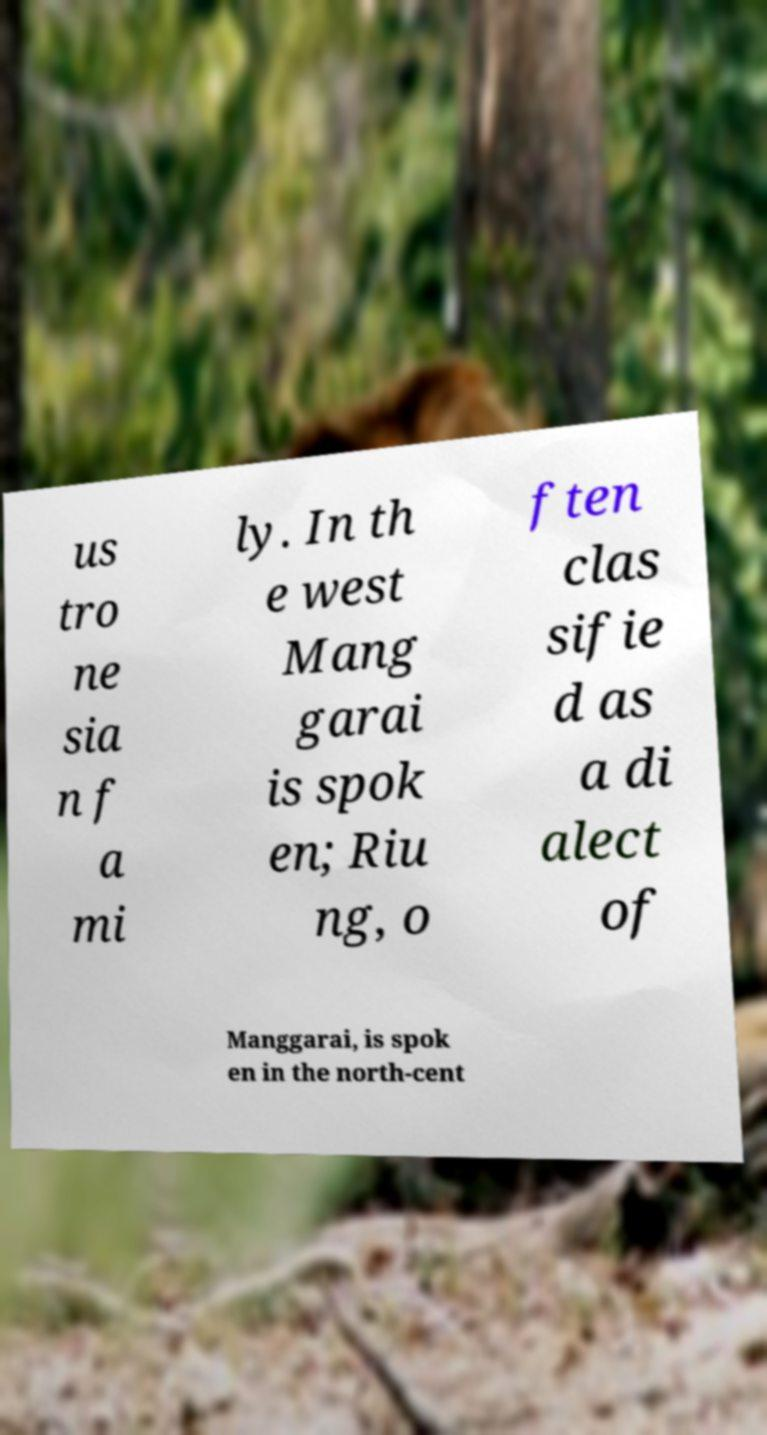Could you assist in decoding the text presented in this image and type it out clearly? us tro ne sia n f a mi ly. In th e west Mang garai is spok en; Riu ng, o ften clas sifie d as a di alect of Manggarai, is spok en in the north-cent 